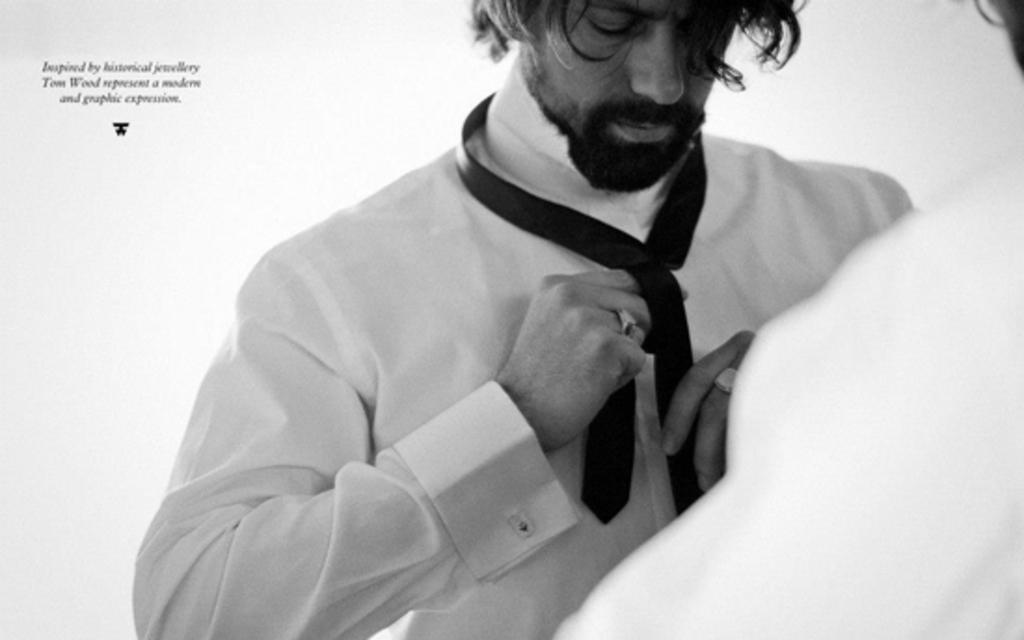What is the main subject of the image? There is a person in the image. What is the person holding in the image? The person is holding a black color tie. What color is the shirt the person is wearing? The person is wearing a white color shirt. What is the color of the background in the image? The background of the image is white. Can you describe any text or writing present in the image? Yes, there is text or writing on the image. What type of throne is the governor sitting on in the image? There is no governor or throne present in the image. What is the person using the hammer for in the image? There is no hammer present in the image. 